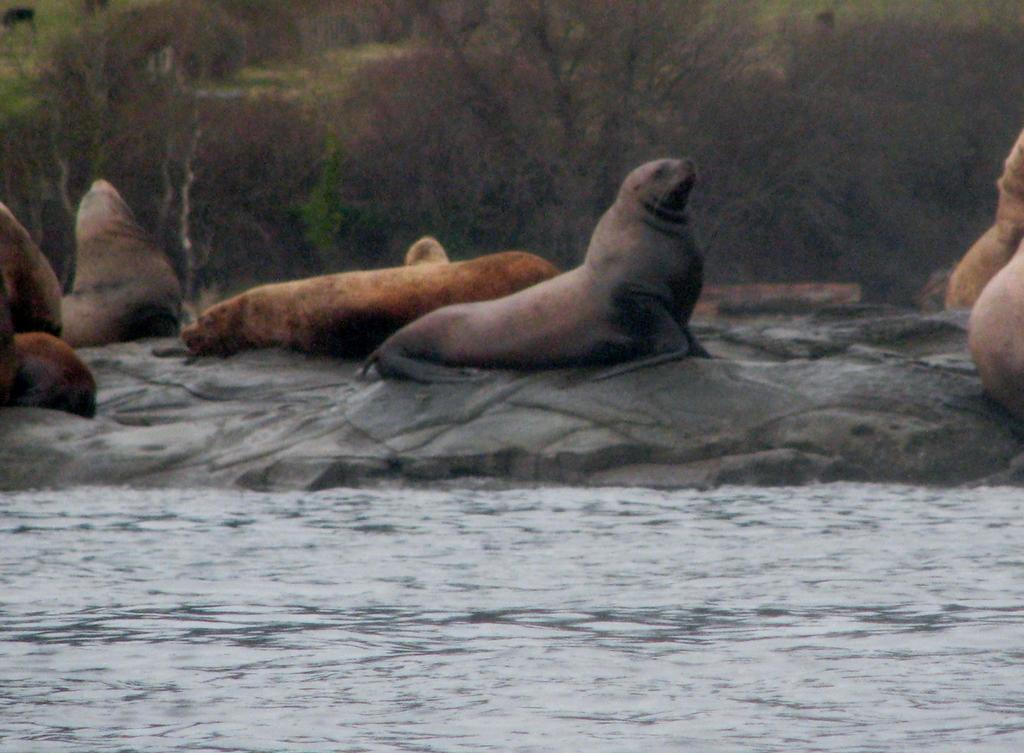What is the primary element visible in the image? There is water in the image. What type of surface can be seen near the water? There is a rocky surface in the image. What is placed on the rocky surface? There are seats on the rocky surface. What colors are the seats? The seats are brown, cream, and black in color. What can be seen in the background of the image? There are trees in the background of the image. How does the bird grip the seats in the image? There are no birds present in the image, so it is not possible to determine how a bird might grip the seats. 